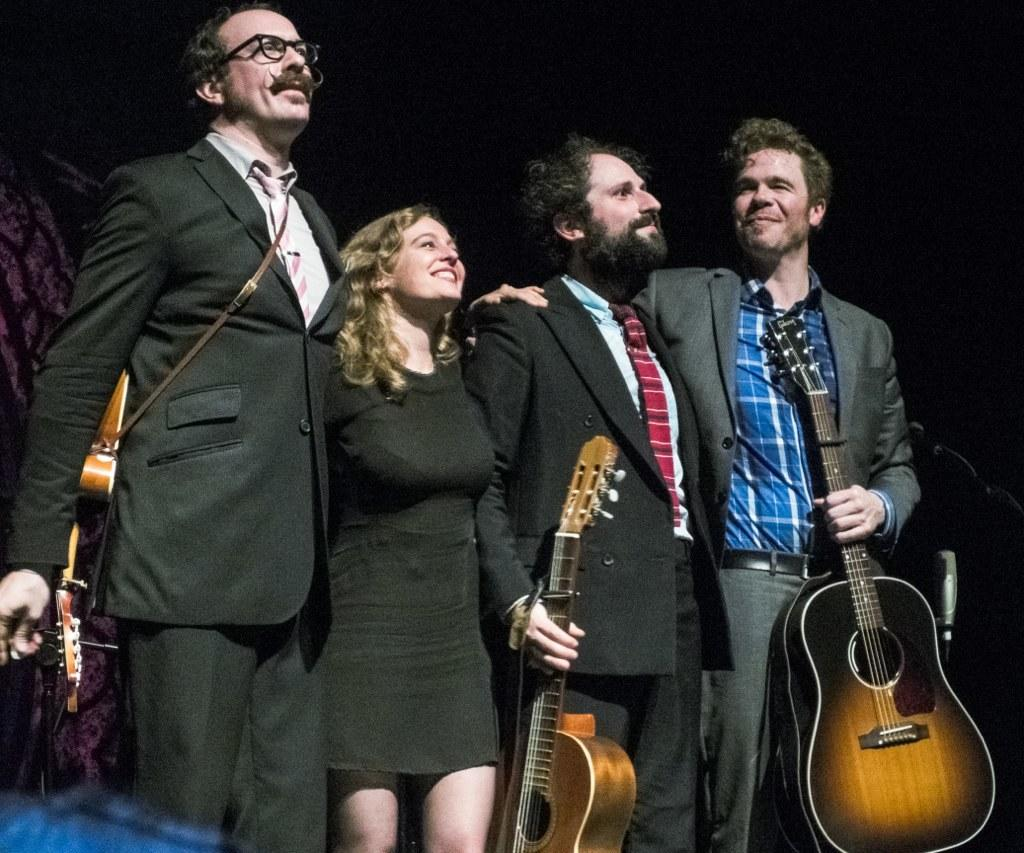How many people are in the image? There are four persons in the image. What are the persons holding in the image? Each person is holding a guitar. What is the facial expression of the persons in the image? The persons are smiling. Can you identify the gender of the persons in the image? One of the persons is a woman, and the remaining three persons are men. What type of bean is being used to play the guitar in the image? There is no bean present in the image, and the persons are playing guitars with their hands, not beans. What show is the woman performing in the image? There is no show or performance mentioned or depicted in the image. 